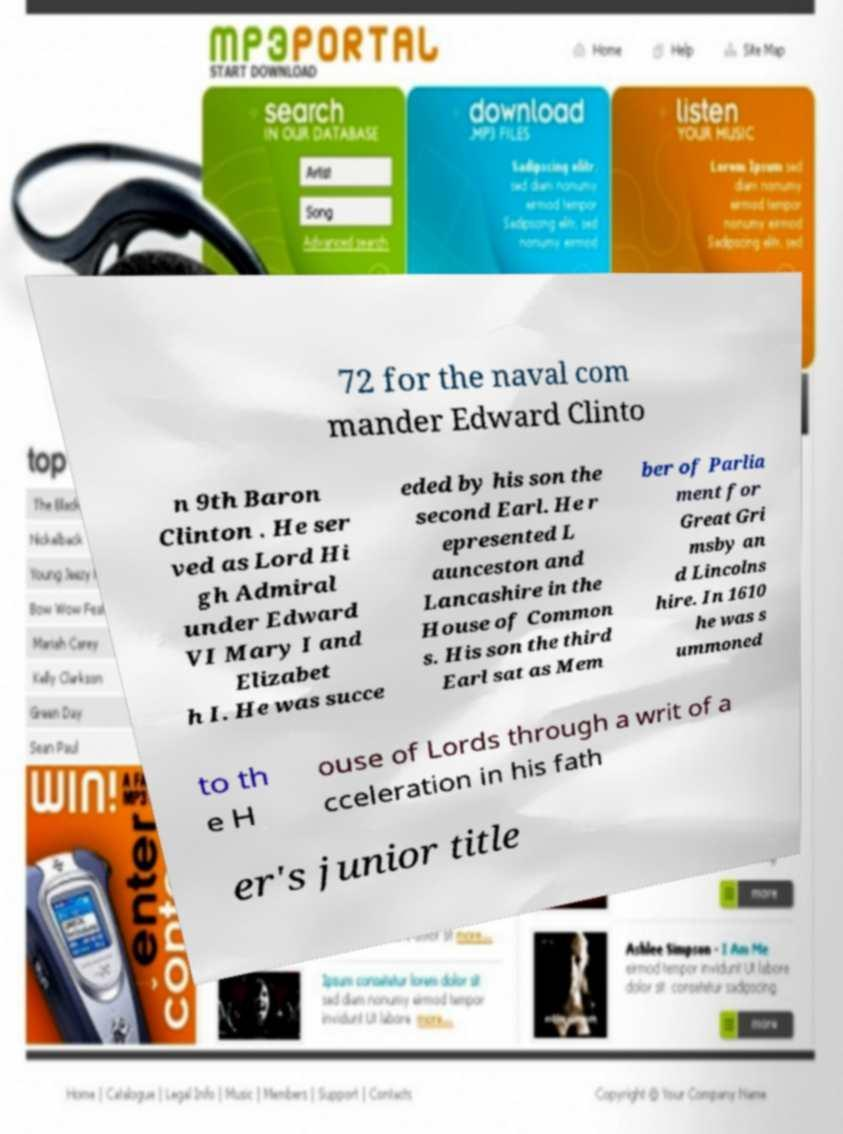Could you extract and type out the text from this image? 72 for the naval com mander Edward Clinto n 9th Baron Clinton . He ser ved as Lord Hi gh Admiral under Edward VI Mary I and Elizabet h I. He was succe eded by his son the second Earl. He r epresented L aunceston and Lancashire in the House of Common s. His son the third Earl sat as Mem ber of Parlia ment for Great Gri msby an d Lincolns hire. In 1610 he was s ummoned to th e H ouse of Lords through a writ of a cceleration in his fath er's junior title 